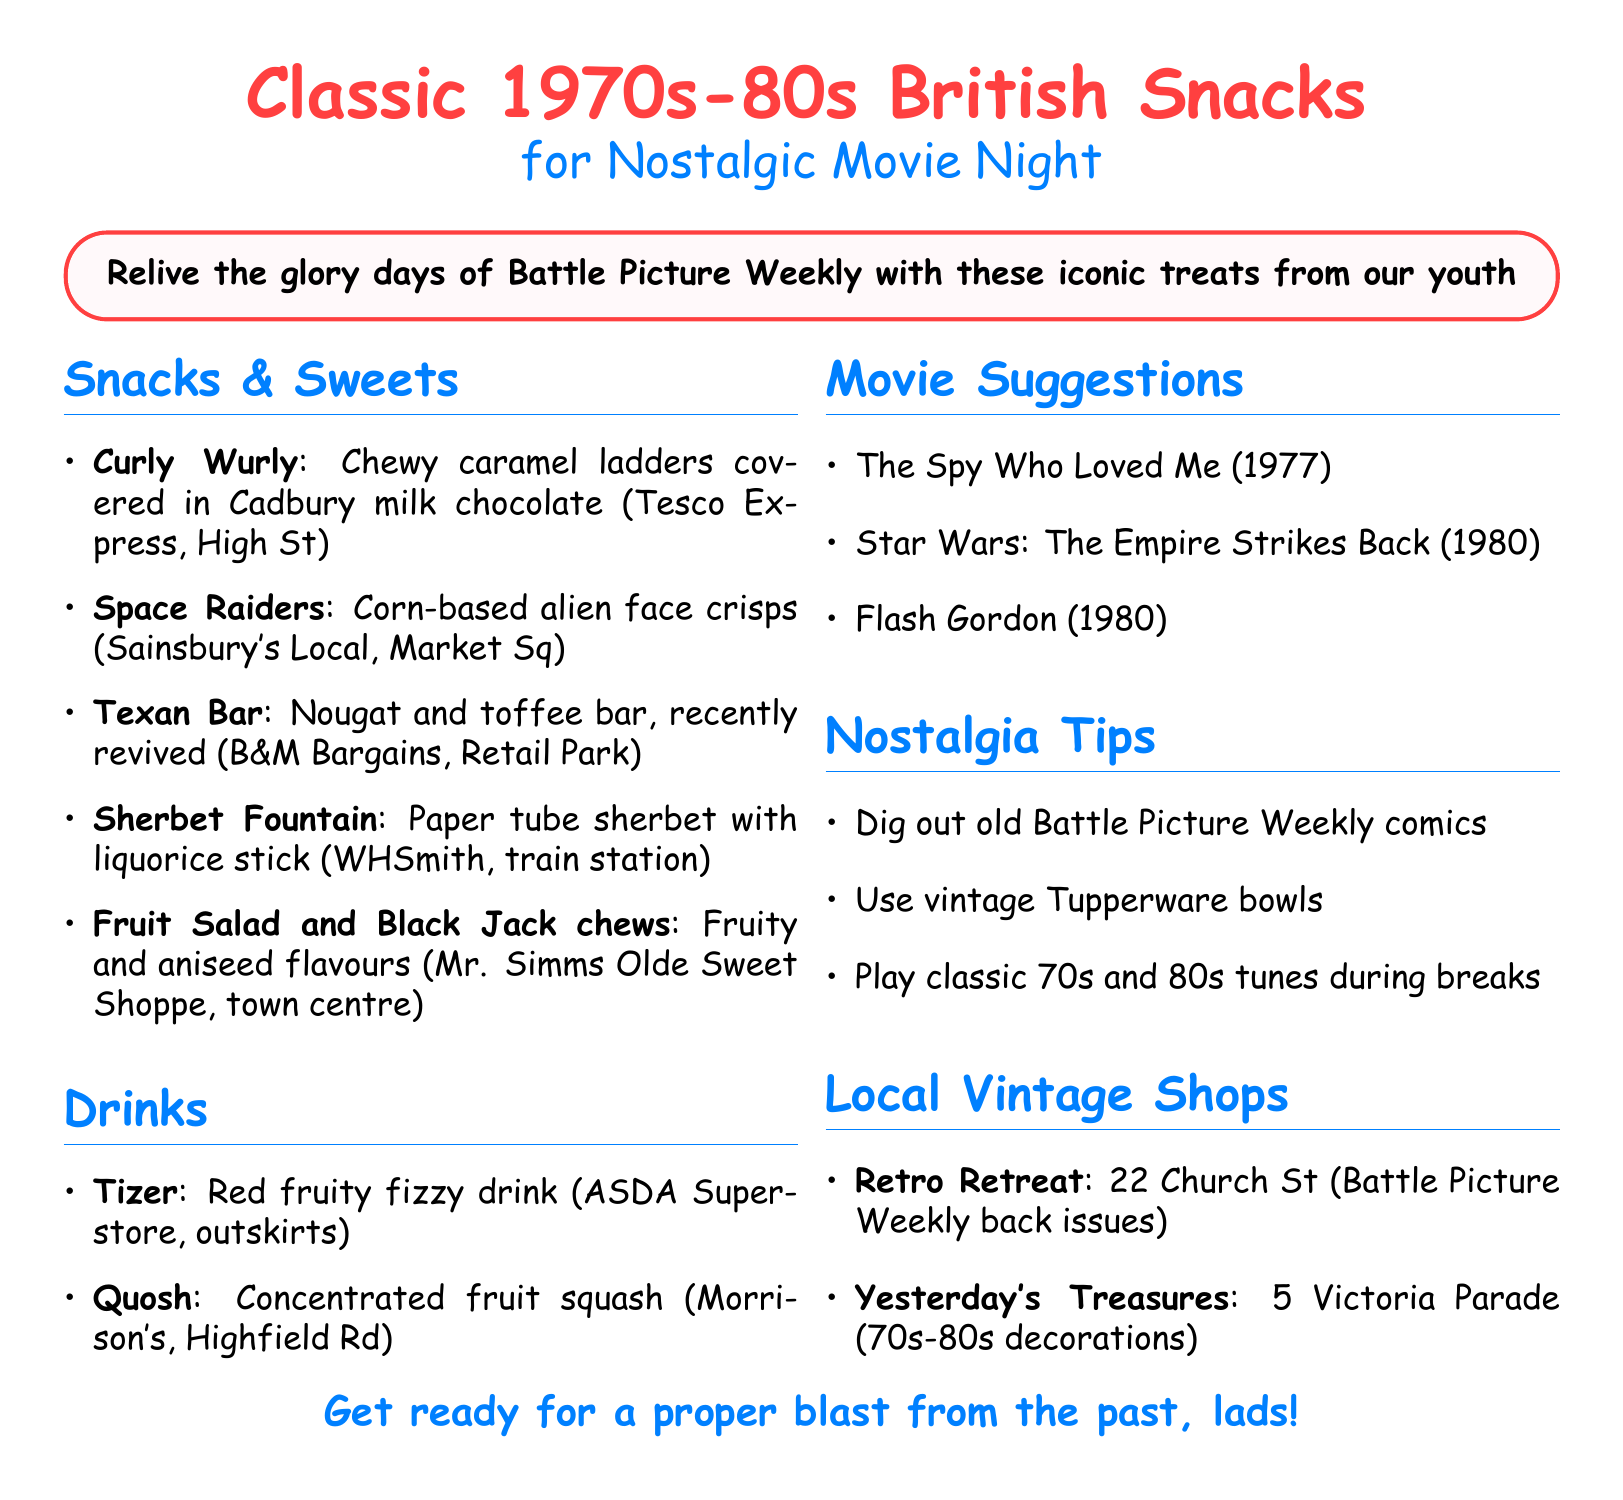what is the name of the first snack listed? The first snack listed in the document is Curly Wurly.
Answer: Curly Wurly where can you buy Space Raiders? The document specifies that Space Raiders can be bought at Sainsbury's Local on Market Square.
Answer: Sainsbury's Local on Market Square how many movie suggestions are provided? The document lists three movie suggestions.
Answer: 3 what is the address of Retro Retreat? The address of Retro Retreat is provided as 22 Church Street.
Answer: 22 Church Street which drink is described as a red fruity fizzy drink? According to the document, Tizer is described as a red fruity fizzy drink.
Answer: Tizer what type of sweets are Fruit Salad and Black Jack? The document states that these are chewy sweets in fruity and aniseed flavours.
Answer: Chewy sweets in fruity and aniseed flavours what nostalgia tip suggests using old comics? One nostalgia tip mentions digging out your old Battle Picture Weekly comics for intermission reading.
Answer: Dig out old Battle Picture Weekly comics which vintage shop specializes in decorations from the 70s and 80s? Yesterday's Treasures is the shop that specializes in nostalgic decorations and tableware from the 70s and 80s.
Answer: Yesterday's Treasures 